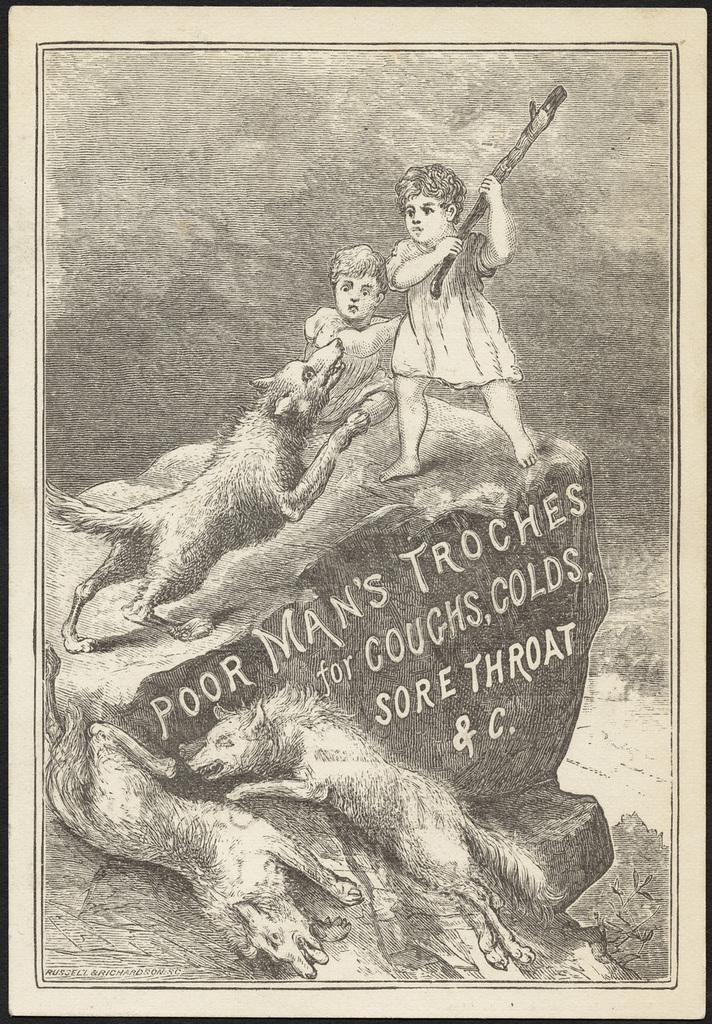Please provide a concise description of this image. This is black and white poster where we can see two children, foxes, rock and some text. 